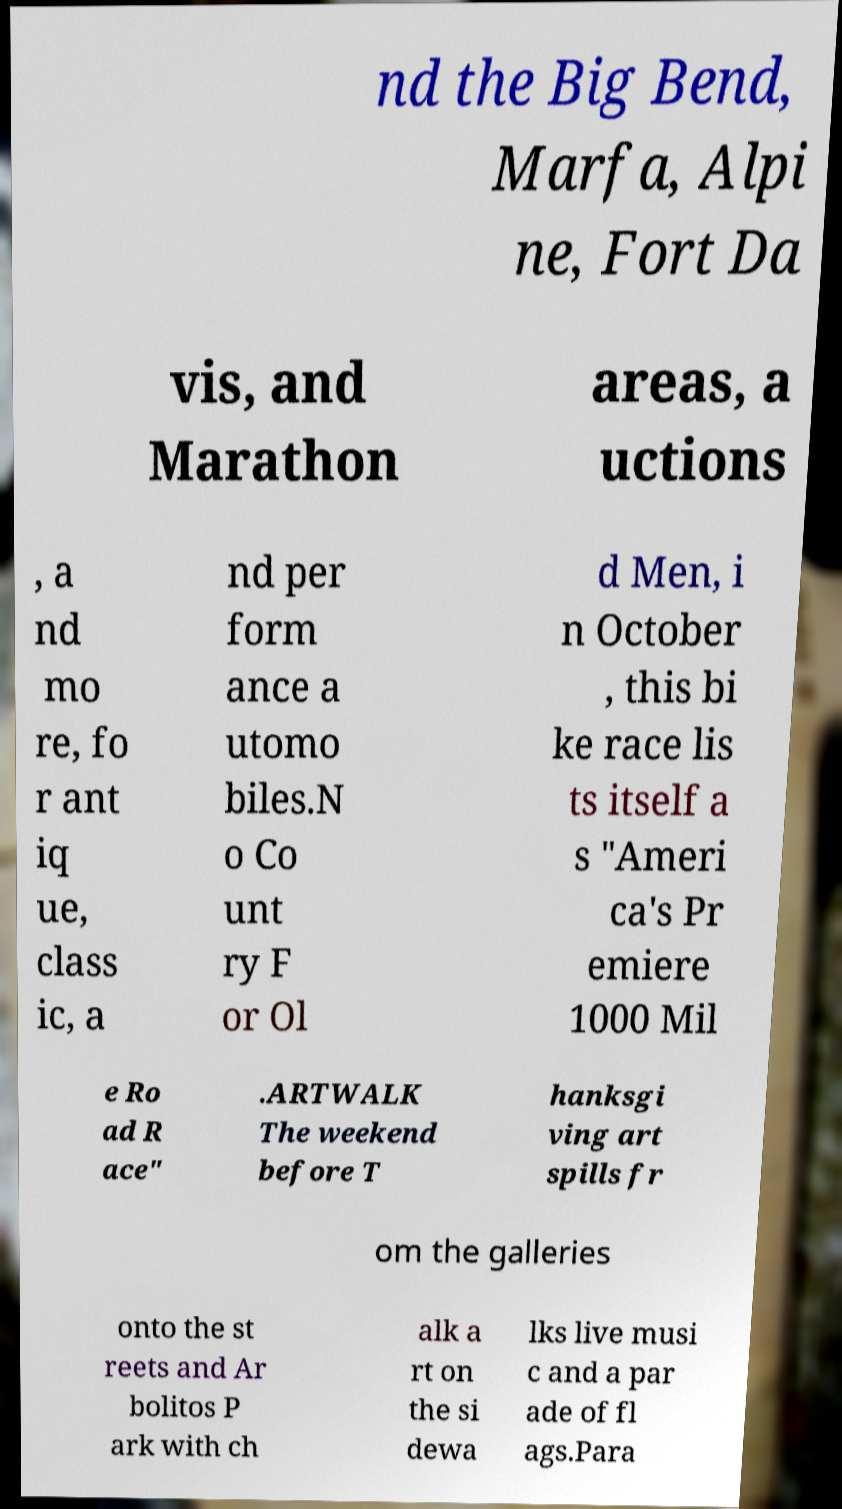Please identify and transcribe the text found in this image. nd the Big Bend, Marfa, Alpi ne, Fort Da vis, and Marathon areas, a uctions , a nd mo re, fo r ant iq ue, class ic, a nd per form ance a utomo biles.N o Co unt ry F or Ol d Men, i n October , this bi ke race lis ts itself a s "Ameri ca's Pr emiere 1000 Mil e Ro ad R ace" .ARTWALK The weekend before T hanksgi ving art spills fr om the galleries onto the st reets and Ar bolitos P ark with ch alk a rt on the si dewa lks live musi c and a par ade of fl ags.Para 